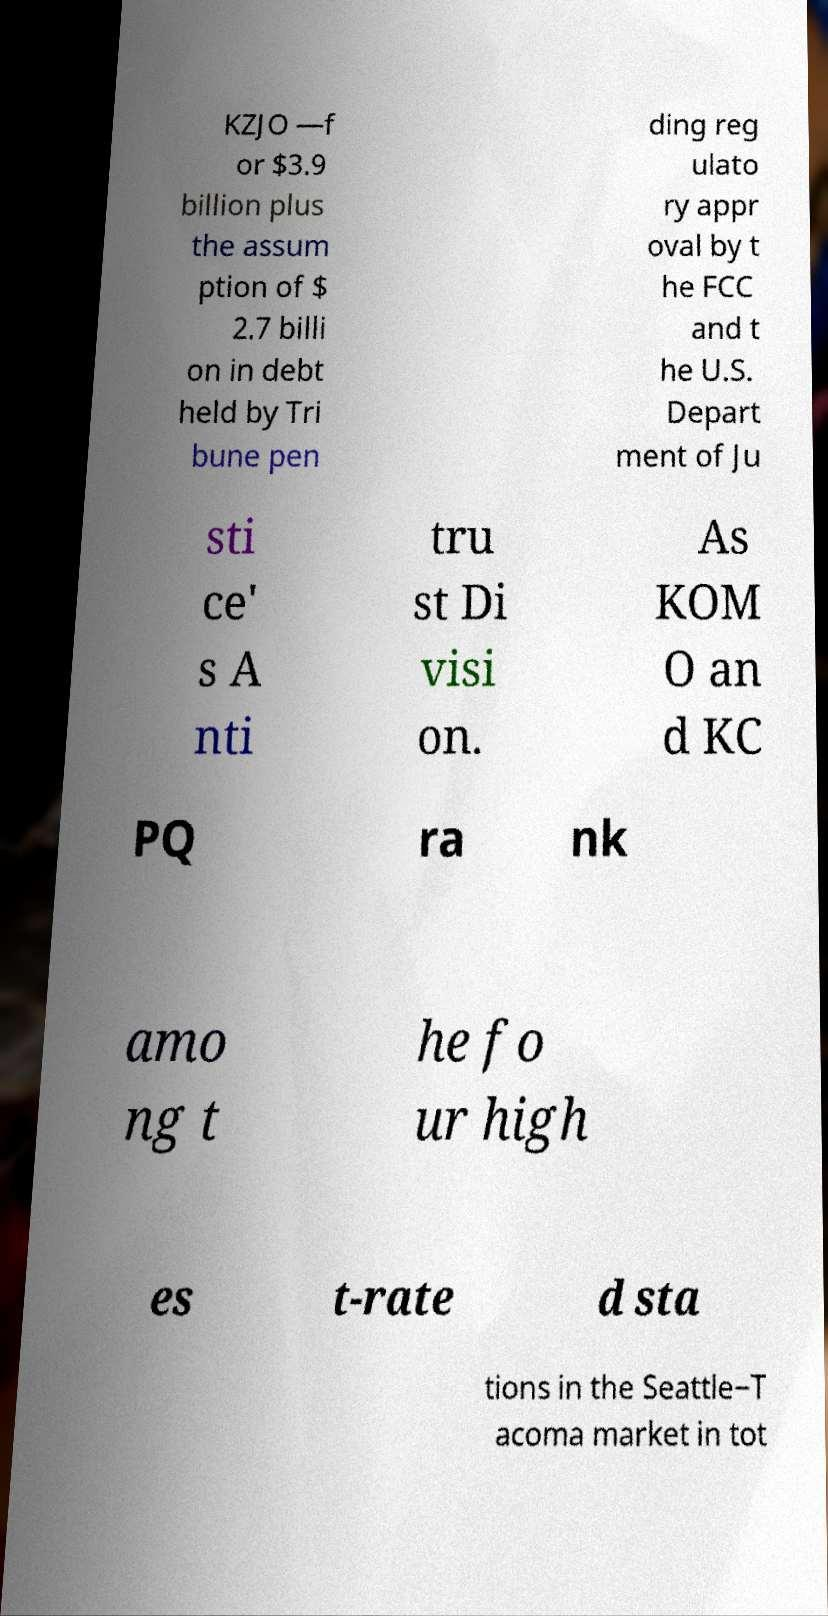Could you extract and type out the text from this image? KZJO —f or $3.9 billion plus the assum ption of $ 2.7 billi on in debt held by Tri bune pen ding reg ulato ry appr oval by t he FCC and t he U.S. Depart ment of Ju sti ce' s A nti tru st Di visi on. As KOM O an d KC PQ ra nk amo ng t he fo ur high es t-rate d sta tions in the Seattle−T acoma market in tot 